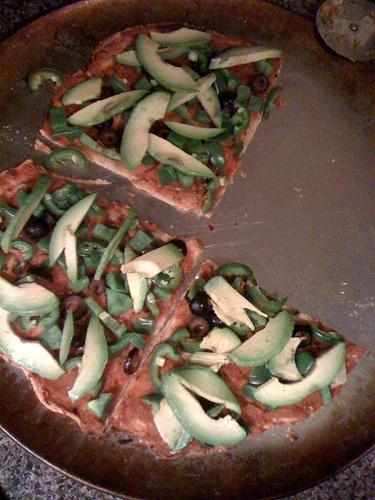What is on the tray? pizza 